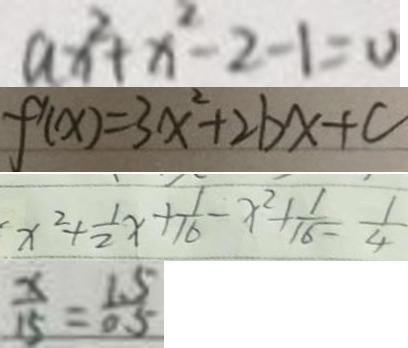<formula> <loc_0><loc_0><loc_500><loc_500>a x ^ { 2 } + x ^ { 2 } - 2 - 1 = 0 
 f ^ { \prime } ( x ) = 3 x ^ { 2 } + 2 b x + c 
 x ^ { 2 } + \frac { 1 } { 2 } x + \frac { 1 } { 1 6 } - x ^ { 2 } + \frac { 1 } { 1 6 } = \frac { 1 } { 4 } 
 \frac { x } { 1 5 } = \frac { 1 . 5 } { 0 . 5 }</formula> 